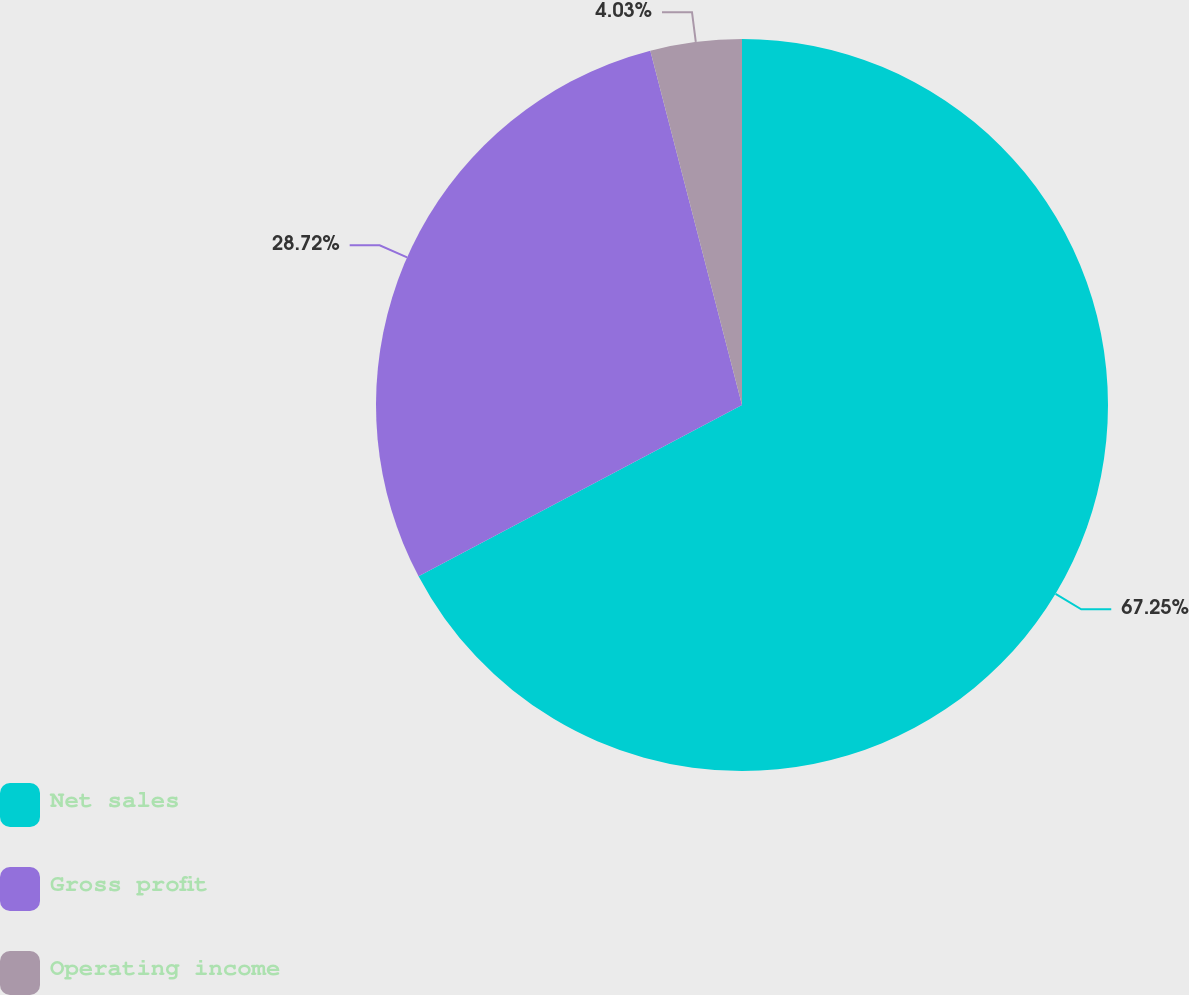<chart> <loc_0><loc_0><loc_500><loc_500><pie_chart><fcel>Net sales<fcel>Gross profit<fcel>Operating income<nl><fcel>67.25%<fcel>28.72%<fcel>4.03%<nl></chart> 